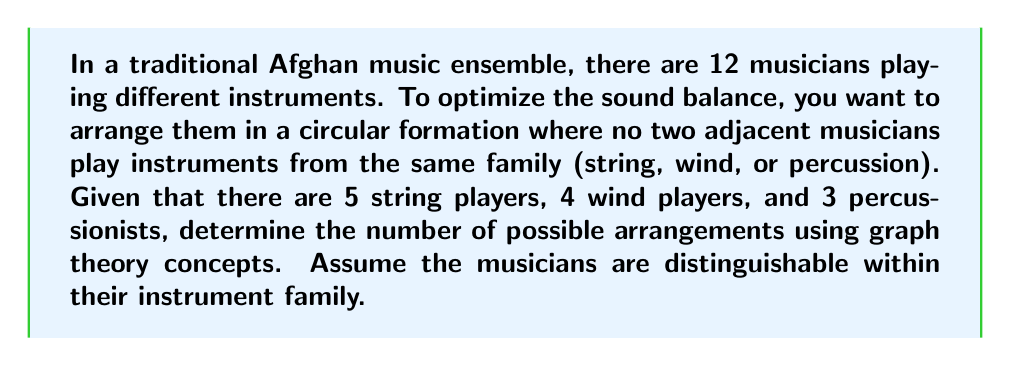Provide a solution to this math problem. To solve this problem, we can use graph theory concepts, specifically the idea of circular permutations with restrictions. Let's approach this step-by-step:

1) First, we can model this as a graph coloring problem. Each musician represents a vertex, and we need to color the graph with 3 colors (representing the instrument families) such that no adjacent vertices have the same color.

2) The problem reduces to finding the number of ways to arrange 5 string players (S), 4 wind players (W), and 3 percussionists (P) in a circle with no two adjacent musicians from the same family.

3) We can use the concept of circular permutations with restrictions. Let's start by placing the string players:

   $$\binom{12}{5}$$ ways to choose positions for string players.

4) Next, we need to place the wind and percussion players in the remaining 7 positions, alternating between them. This is equivalent to choosing positions for one group (say, wind) and filling the rest with percussion.

5) There are $$\binom{7}{4}$$ ways to choose positions for wind players among the remaining 7 positions.

6) Once we've placed string and wind players, the positions of percussion players are fixed.

7) Now, we need to consider the arrangements within each group:
   - 5! ways to arrange string players
   - 4! ways to arrange wind players
   - 3! ways to arrange percussionists

8) Combining all these factors, we get:

   $$\binom{12}{5} \cdot \binom{7}{4} \cdot 5! \cdot 4! \cdot 3!$$

9) Calculate:
   $$792 \cdot 35 \cdot 120 \cdot 24 \cdot 6 = 47,900,160$$

However, we've overcounted by a factor of 12 because rotations of the same arrangement are considered identical in a circular formation. So we need to divide by 12.

Final calculation: $$\frac{47,900,160}{12} = 3,991,680$$
Answer: The number of possible arrangements is 3,991,680. 